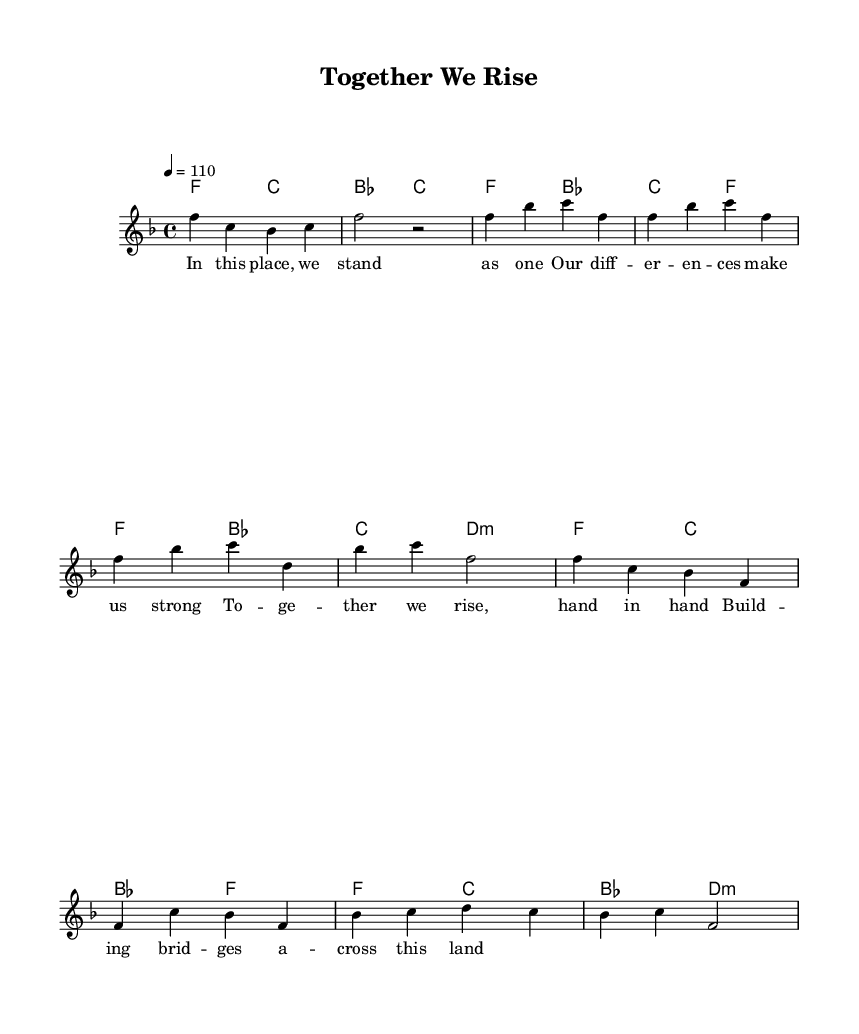What is the key signature of this music? The key signature is F major, which has one flat (B flat). You can identify the key signature by looking at the beginning of the staff, right after the clef sign, where the flats and sharps are indicated.
Answer: F major What is the time signature of this piece? The time signature is 4/4. This is indicated on the staff right after the key signature. The top number (4) indicates there are four beats in a measure, and the bottom number (4) indicates a quarter note gets one beat.
Answer: 4/4 What is the tempo marking of the piece? The tempo marking indicates a speed of 110 beats per minute. It's specified at the start of the piece in the tempo instructions using the notation '4 = 110'. This tells players the pace at which the music should be played.
Answer: 110 How many measures are in the chorus? The chorus consists of 4 measures, as observed in the sheet music which displays a total of four sets of notes grouped together under the chorus section. Each group of notes represents one measure.
Answer: 4 What is the mood conveyed by the lyrics? The mood is uplifting and united, suggesting togetherness and strength in diversity, as expressed by the phrases in the lyrics dedicated to collaboration and building bridges. The overall message of the lyrics promotes positivity and teamwork.
Answer: Uplifting Which musical element connects the verses to the chorus in this piece? The chord progression connects the verses to the chorus. By observing the harmonies section, it is clear that the chord changes are consistent throughout both sections, which creates a sense of continuity as the music transitions from verse to chorus.
Answer: Chord progression 